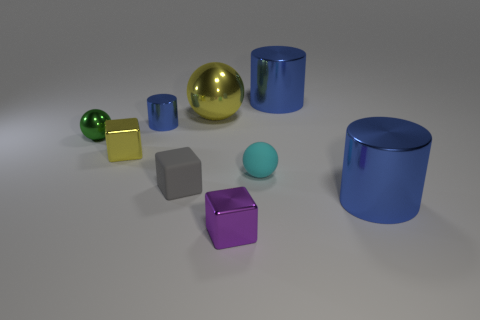Subtract all blocks. How many objects are left? 6 Subtract 0 yellow cylinders. How many objects are left? 9 Subtract all brown metallic objects. Subtract all small cyan spheres. How many objects are left? 8 Add 6 tiny blue objects. How many tiny blue objects are left? 7 Add 5 big gray rubber cylinders. How many big gray rubber cylinders exist? 5 